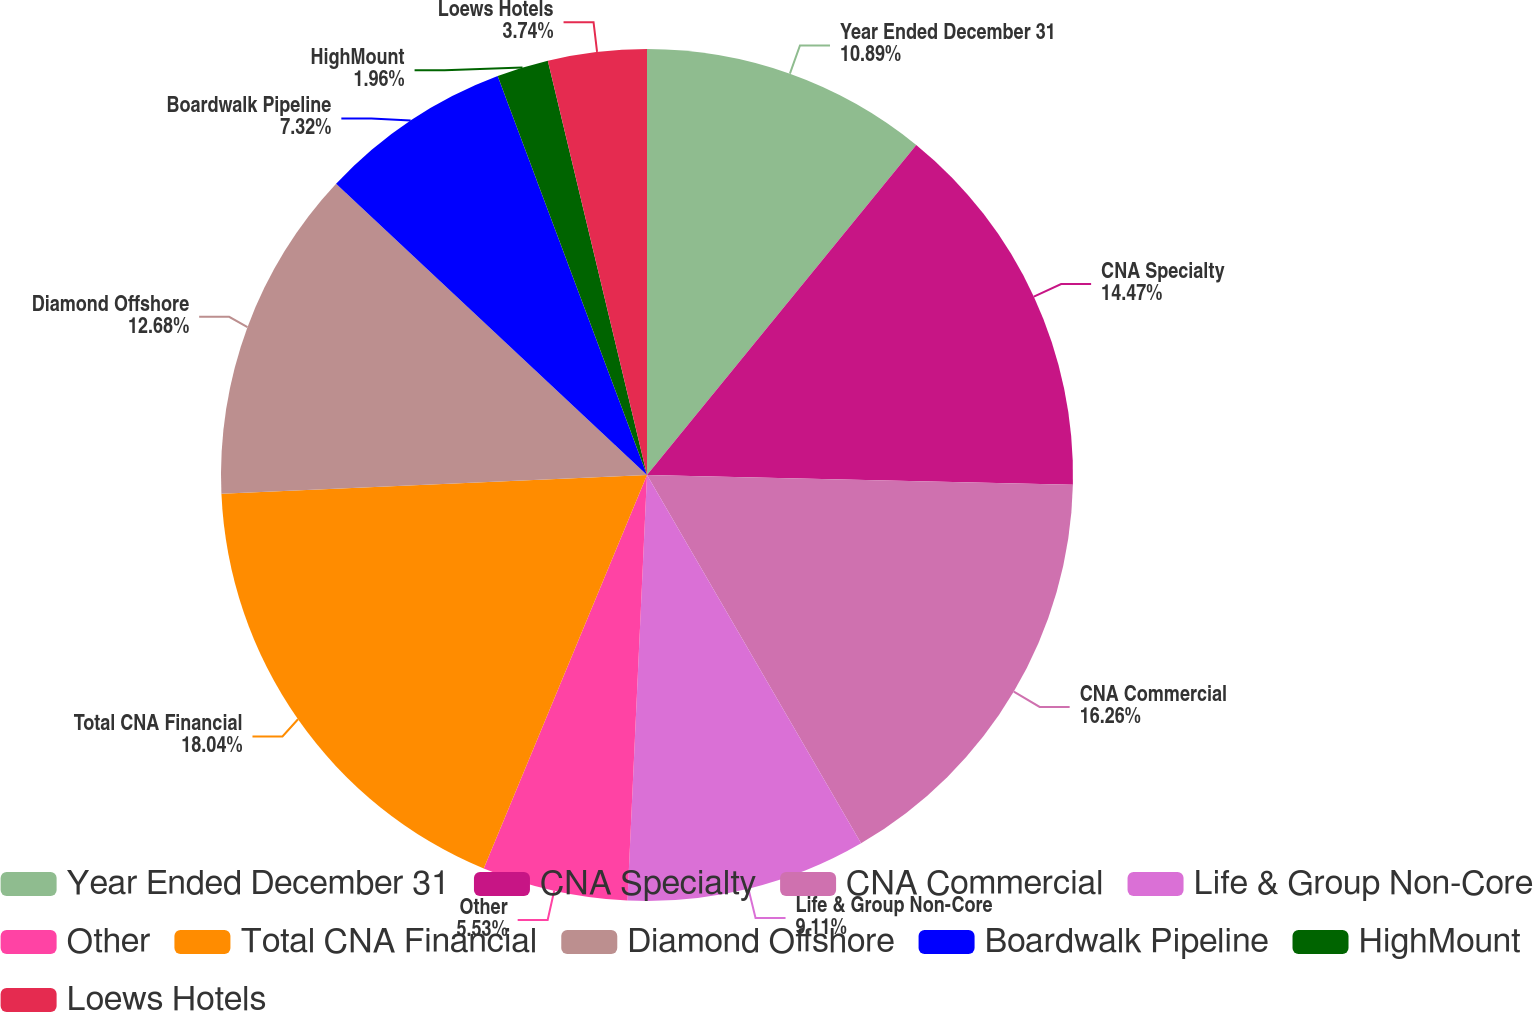<chart> <loc_0><loc_0><loc_500><loc_500><pie_chart><fcel>Year Ended December 31<fcel>CNA Specialty<fcel>CNA Commercial<fcel>Life & Group Non-Core<fcel>Other<fcel>Total CNA Financial<fcel>Diamond Offshore<fcel>Boardwalk Pipeline<fcel>HighMount<fcel>Loews Hotels<nl><fcel>10.89%<fcel>14.47%<fcel>16.26%<fcel>9.11%<fcel>5.53%<fcel>18.04%<fcel>12.68%<fcel>7.32%<fcel>1.96%<fcel>3.74%<nl></chart> 